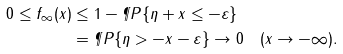Convert formula to latex. <formula><loc_0><loc_0><loc_500><loc_500>0 \leq f _ { \infty } ( x ) & \leq 1 - \P P \{ \eta + x \leq - \varepsilon \} \\ & = \P P \{ \eta > - x - \varepsilon \} \to 0 \quad ( x \to - \infty ) .</formula> 